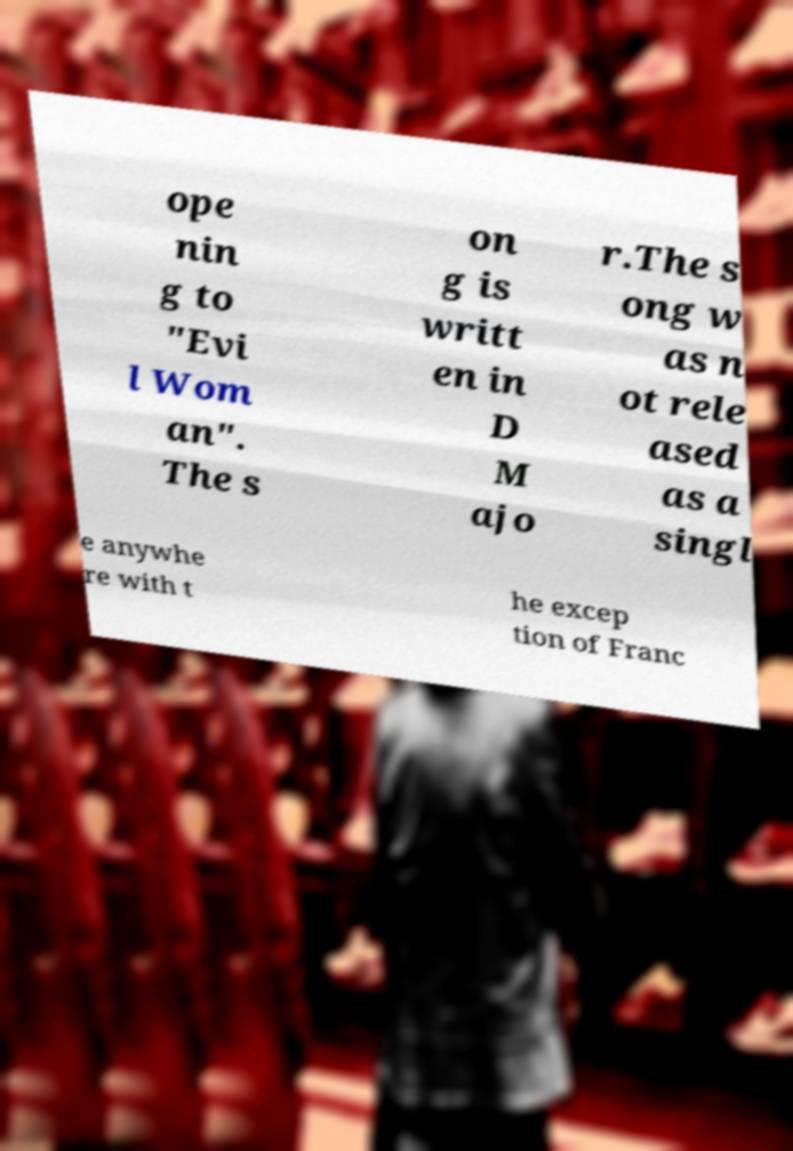Please identify and transcribe the text found in this image. ope nin g to "Evi l Wom an". The s on g is writt en in D M ajo r.The s ong w as n ot rele ased as a singl e anywhe re with t he excep tion of Franc 